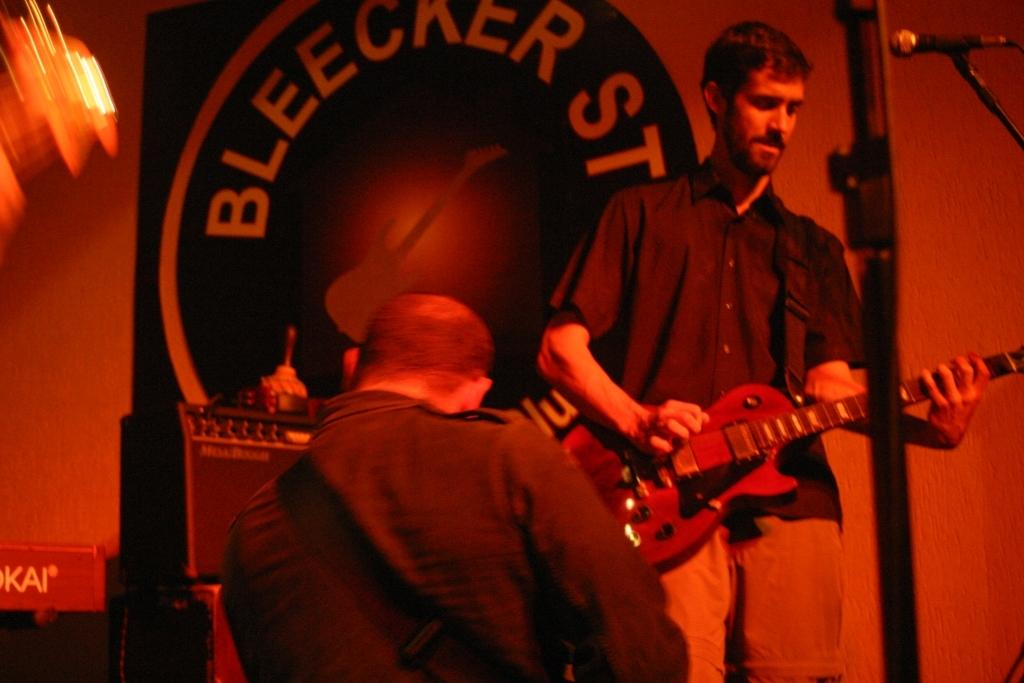How many people are in the image? There are two persons in the image. What are the two persons holding? The two persons are holding guitars. What object is present for amplifying sound? There is a microphone in the image. What can be seen hanging in the background? There is a banner in the image. What type of structure is visible in the background? There is a wall in the image. What type of engine can be seen powering the ball in the image? There is no engine or ball present in the image. 